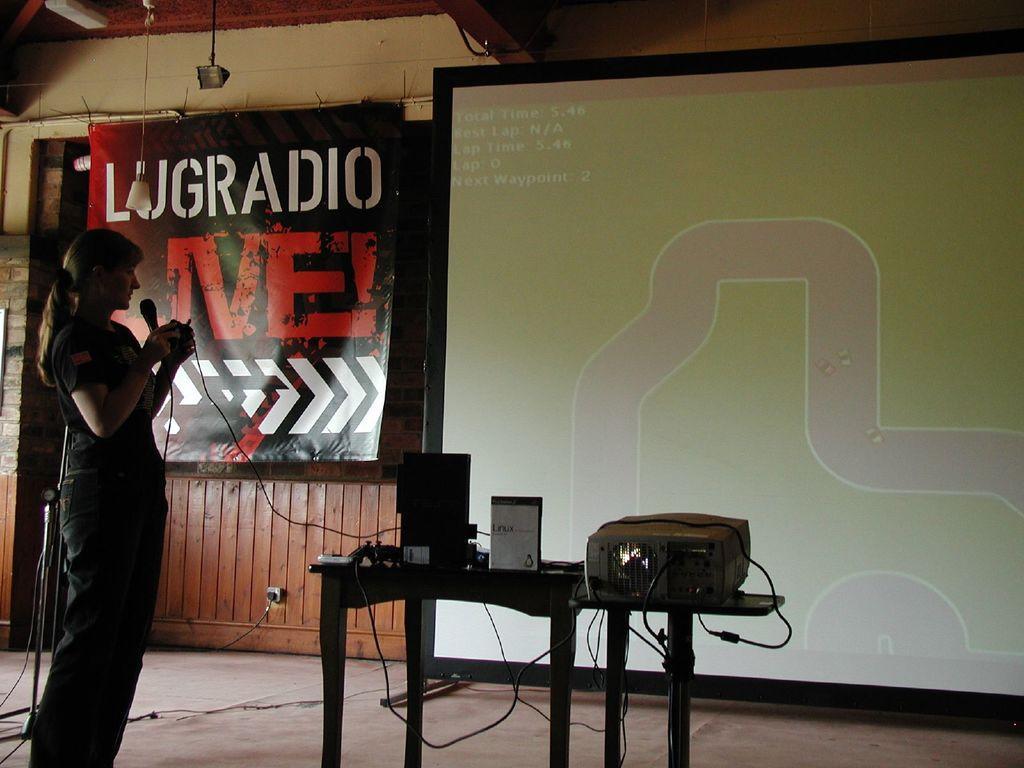Could you give a brief overview of what you see in this image? In this picture there is a woman standing she is holding a microphone in her hand 